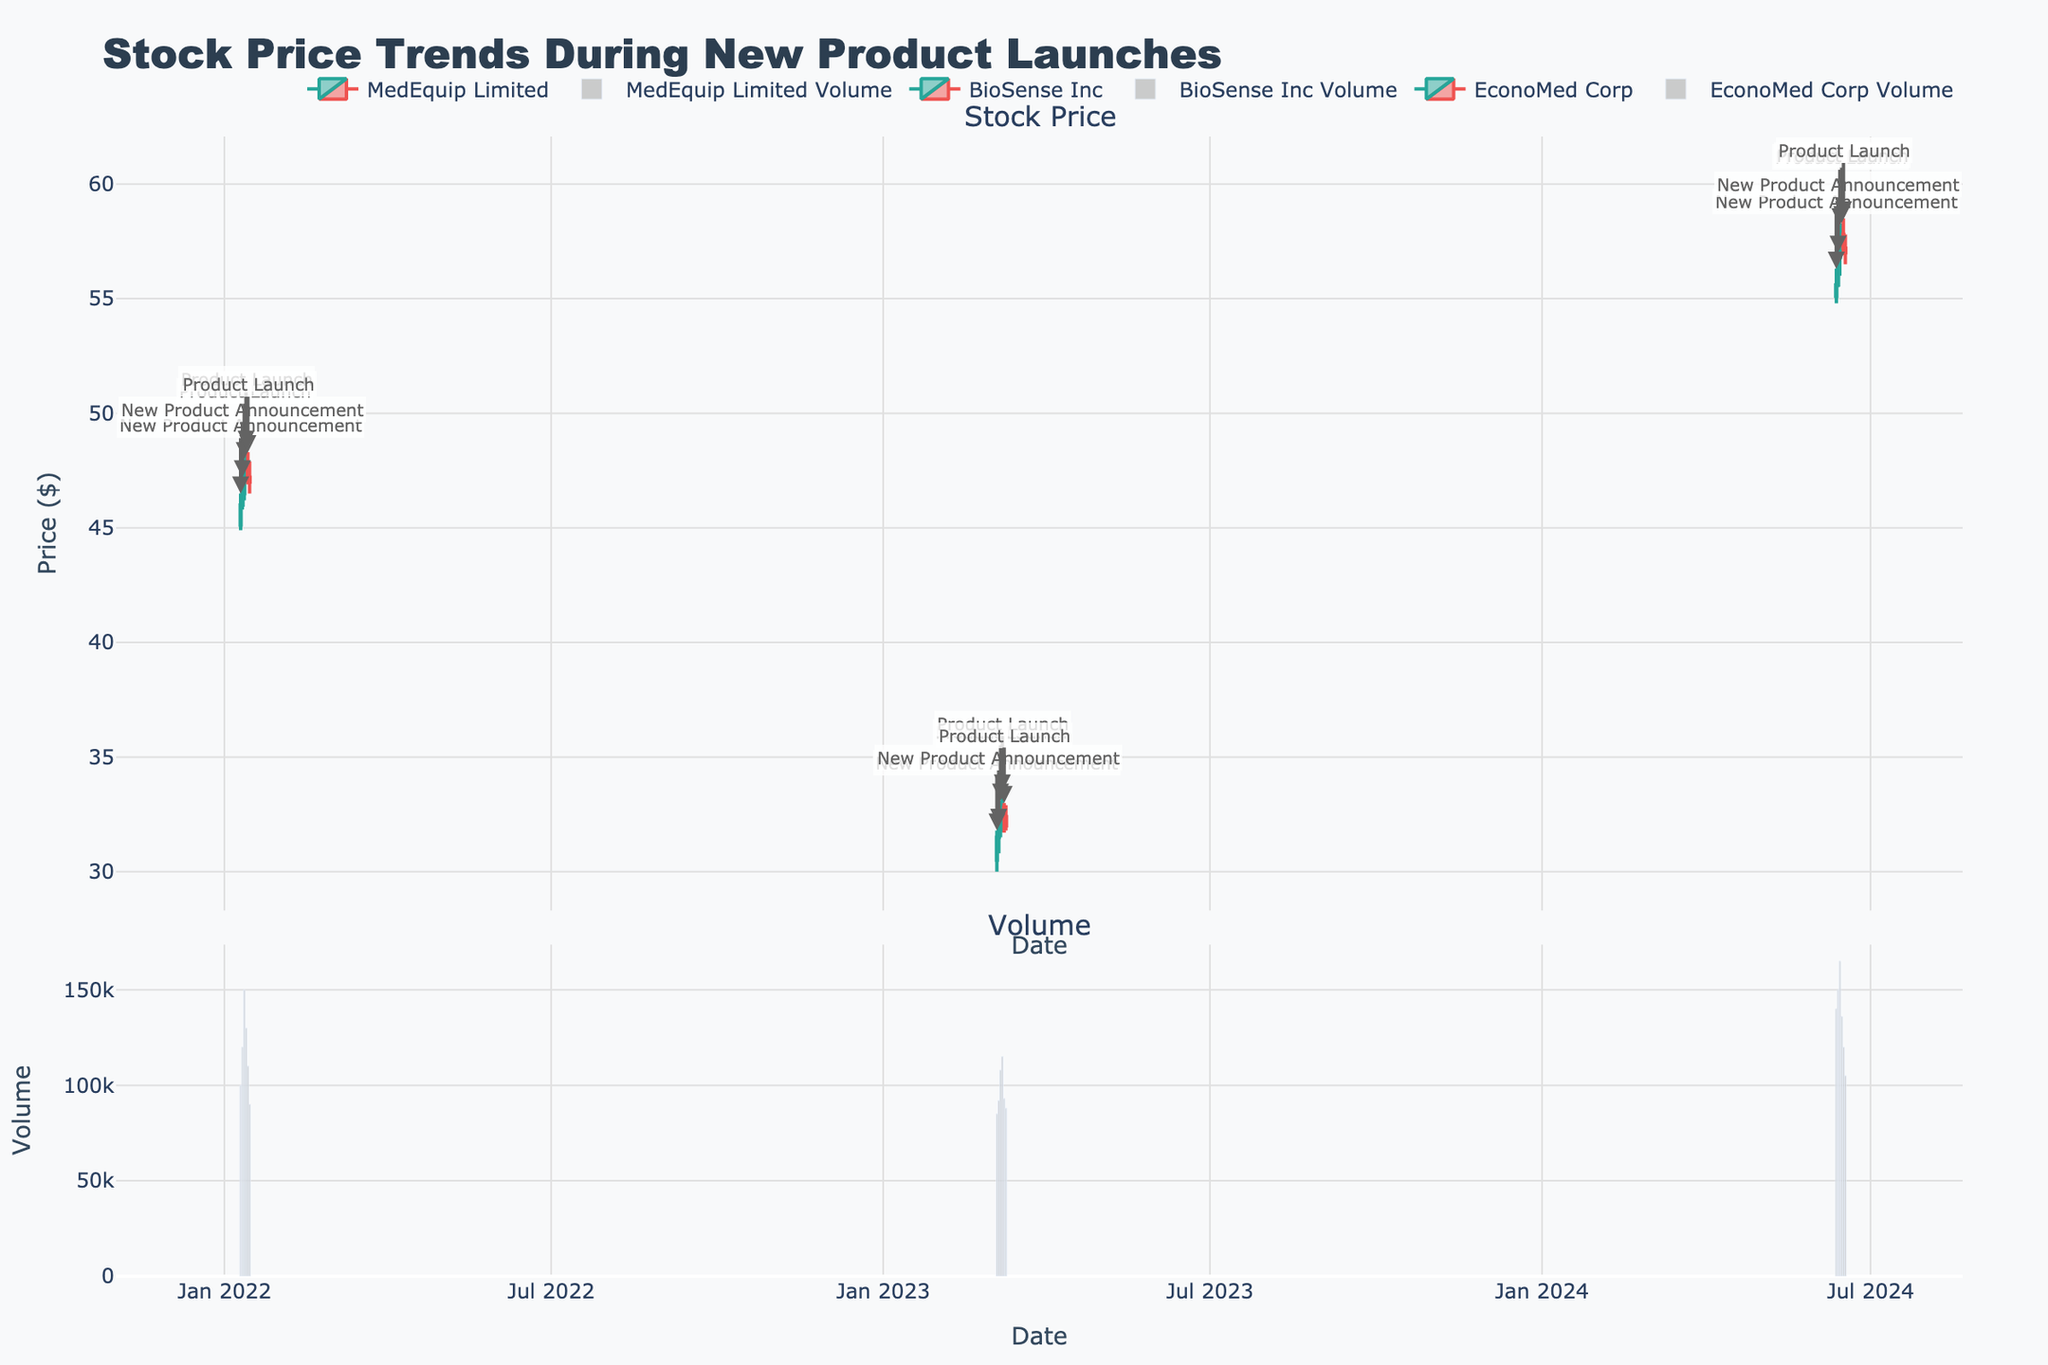What is the overall trend of MedEquip Limited's stock price during the product launch period? The stock price for MedEquip Limited shows an initial upward trend from $46.00 to $47.80, then it reverses, closing at $47.00 at the end of the period. Observing the candlesticks from January 10 to January 15 indicates a rise followed by a slight decline.
Answer: Upward first, then downward How did BioSense Inc's stock price change during the new product announcement phase? BioSense Inc's stock price increased from $30.50 to $31.50 from March 5 to March 6 during the new product announcement phase, indicating a positive market reaction.
Answer: Increase Which company's stock showed the highest volume during their respective product launch phase? By comparing the volume bars, EconoMed Corp had the highest volume on June 14, with 165,000 shares traded during their product launch.
Answer: EconoMed Corp What was the opening price of EconoMed Corp's stock on the day of the product launch? The opening price of EconoMed Corp on the day of the product launch (June 14) was $56.80, as indicated by the candlestick plot.
Answer: $56.80 Which event had the biggest immediate positive impact on MedEquip Limited's stock price? During the product launch (January 12), MedEquip Limited’s stock price saw a significant increase from $46.50 to $47.50, indicating a positive immediate impact.
Answer: Product Launch Compare the closing prices of the three companies on the last day of the market reaction period. Which company's stock price fared best? By looking at the last candlesticks of each company: MedEquip Limited closed at $47.00 on January 15, BioSense Inc closed at $32.00 on March 10, and EconoMed Corp closed at $57.00 on June 17. EconoMed Corp had the highest closing price.
Answer: EconoMed Corp How did BioSense Inc's stock price fluctuate during the product launch period? BioSense Inc's stock price increased from $31.80 to $32.50 on March 7, and it finally decreased to $32.40 on March 9, showing slight overall instability but minimal fluctuation.
Answer: Fluctuated minimally What is the volume trend for MedEquip Limited during the new product announcement and product launch phases? MedEquip Limited's trading volume started at 100,000 and peaked at 150,000 during the product launch on January 12, then gradually declined afterward. The volume trend shows an initial increase followed by a decrease.
Answer: Increase then decrease Did any of the companies' stock prices experience a decline immediately after the product launch? All three companies experienced some decline in stock prices shortly after their product launches: MedEquip Limited on January 14, BioSense Inc on March 9, and EconoMed Corp on June 16.
Answer: Yes What's the average closing price of MedEquip Limited's stock during the entire period shown in the figure? To find the average, sum the closing prices ($46.00 + $46.50 + $47.50 + $47.80 + $47.20 + $47.00) and divide by the number of days (6). The total is $282.00, and the average is $282.00/6 = $47.00.
Answer: $47.00 